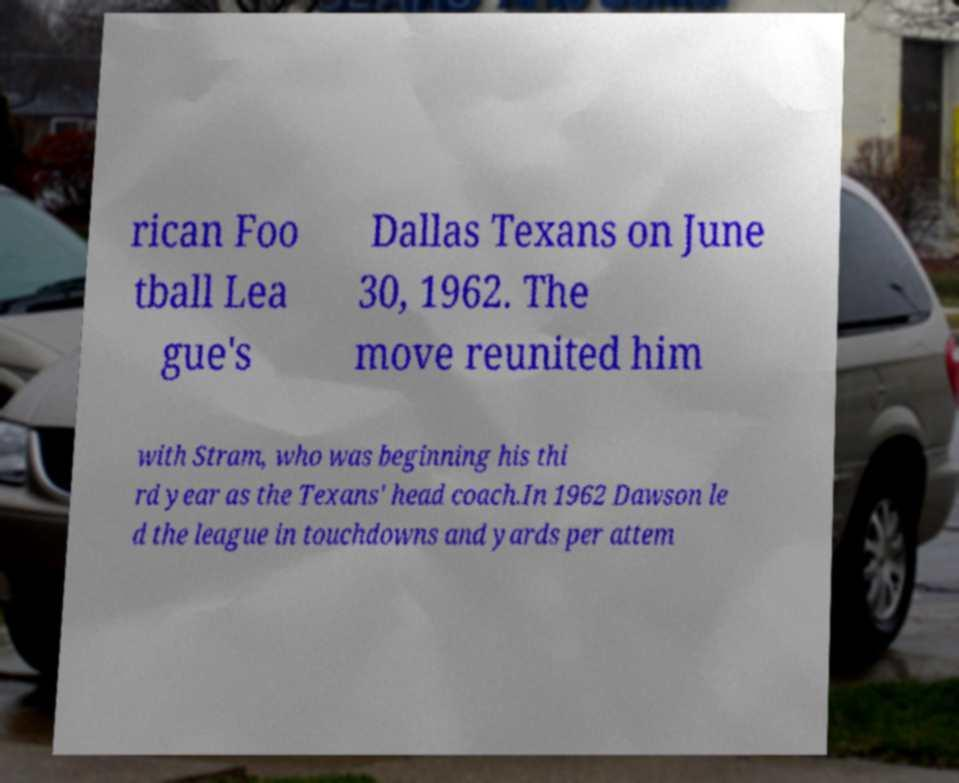Can you accurately transcribe the text from the provided image for me? rican Foo tball Lea gue's Dallas Texans on June 30, 1962. The move reunited him with Stram, who was beginning his thi rd year as the Texans' head coach.In 1962 Dawson le d the league in touchdowns and yards per attem 